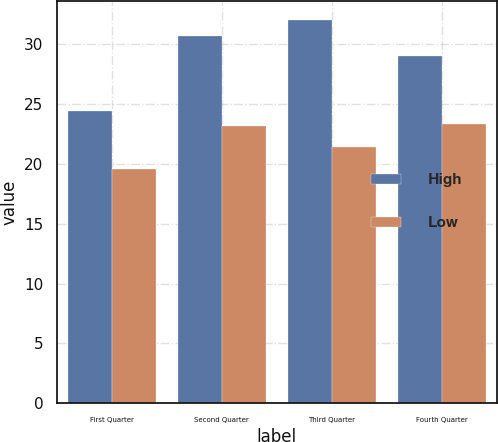Convert chart. <chart><loc_0><loc_0><loc_500><loc_500><stacked_bar_chart><ecel><fcel>First Quarter<fcel>Second Quarter<fcel>Third Quarter<fcel>Fourth Quarter<nl><fcel>High<fcel>24.4<fcel>30.67<fcel>32.01<fcel>29<nl><fcel>Low<fcel>19.56<fcel>23.1<fcel>21.37<fcel>23.27<nl></chart> 